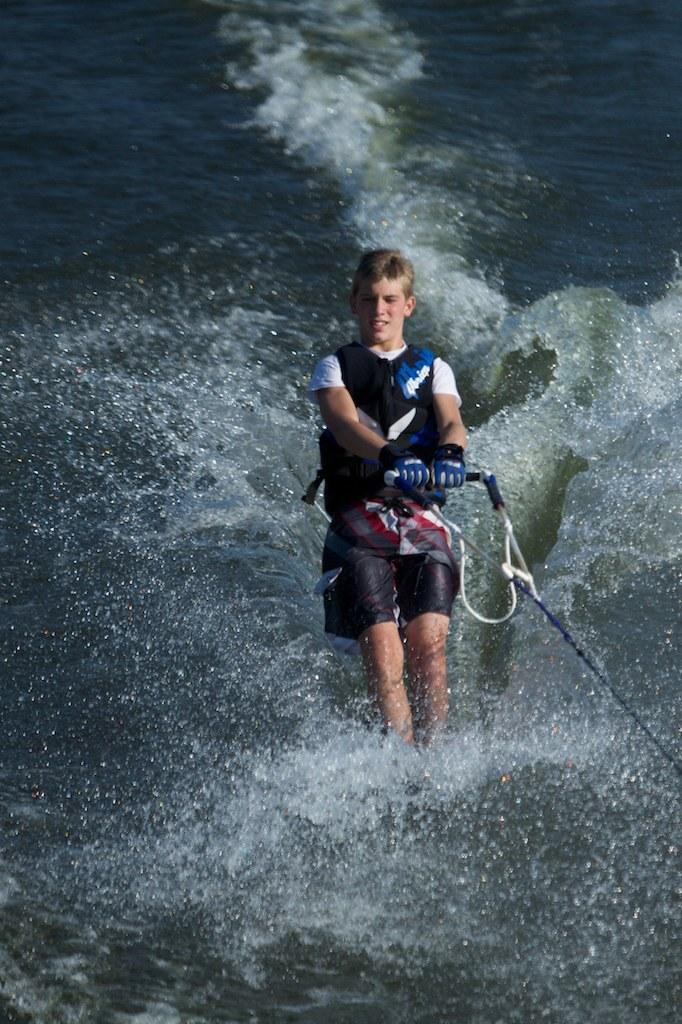What is the main subject of the image? There is a person in the image. What is the person doing in the image? The person is surfing in the water. What is the person holding while surfing? The person is holding surf ropes. What type of copper material can be seen in the image? There is no copper material present in the image. What news event is being reported by the person in the image? The image does not depict a news event or a person reporting news. 